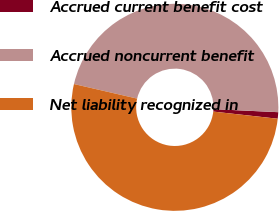<chart> <loc_0><loc_0><loc_500><loc_500><pie_chart><fcel>Accrued current benefit cost<fcel>Accrued noncurrent benefit<fcel>Net liability recognized in<nl><fcel>1.01%<fcel>47.14%<fcel>51.85%<nl></chart> 